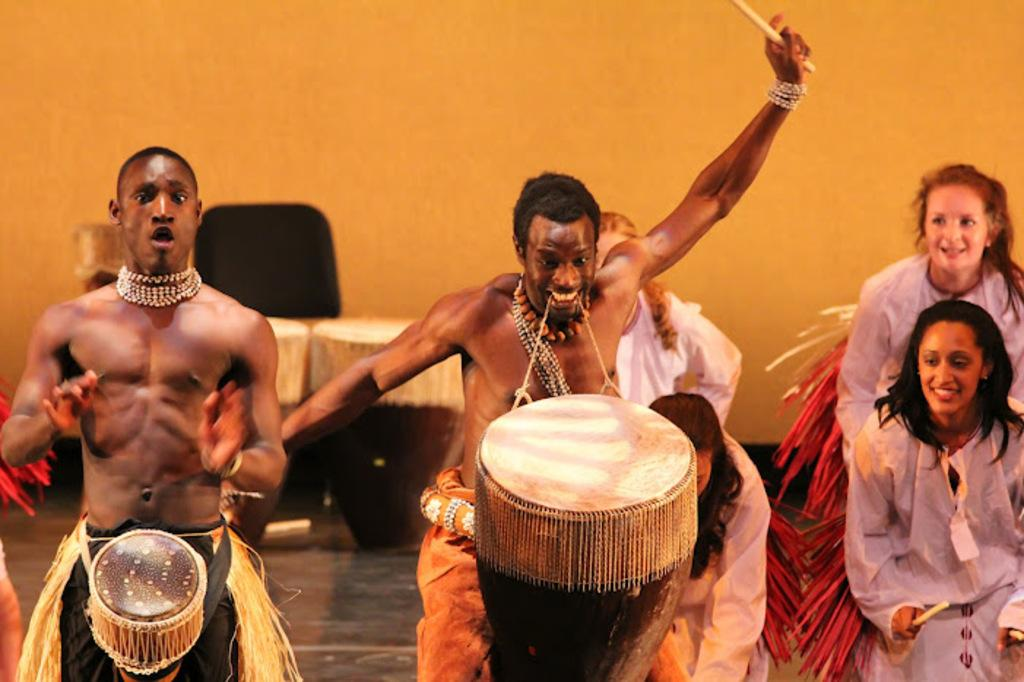What are the people in the image doing? The group of men and women in the image are playing drums. What objects can be seen in the image besides the people? There is a table and a chair in the image. How many cents are visible on the table in the image? There are no cents visible on the table in the image. Is there a window in the image? The provided facts do not mention a window, so we cannot determine if there is one in the image. 